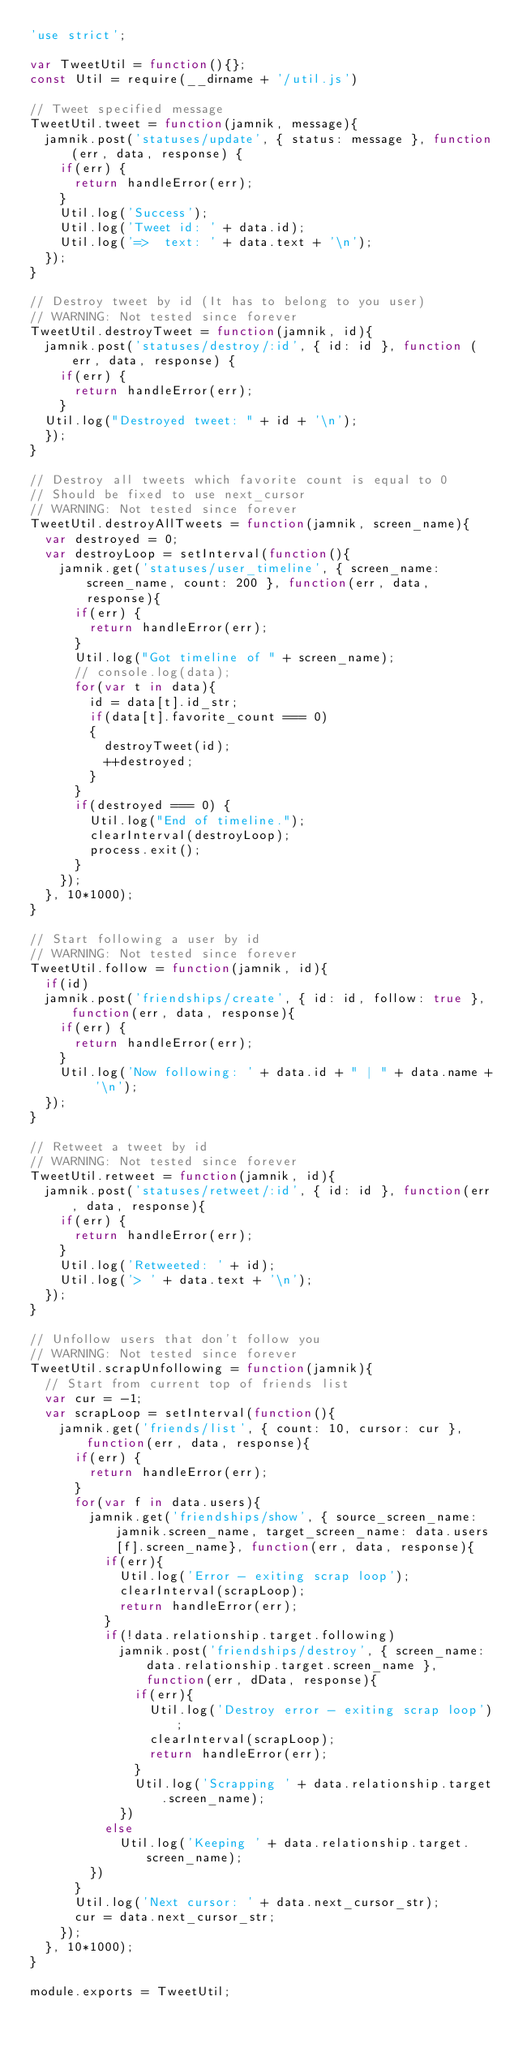<code> <loc_0><loc_0><loc_500><loc_500><_JavaScript_>'use strict';

var TweetUtil = function(){};
const Util = require(__dirname + '/util.js')

// Tweet specified message
TweetUtil.tweet = function(jamnik, message){
  jamnik.post('statuses/update', { status: message }, function(err, data, response) {
    if(err) {
      return handleError(err);
    }
    Util.log('Success');
    Util.log('Tweet id: ' + data.id);
    Util.log('=>  text: ' + data.text + '\n');
  });
}

// Destroy tweet by id (It has to belong to you user)
// WARNING: Not tested since forever
TweetUtil.destroyTweet = function(jamnik, id){
  jamnik.post('statuses/destroy/:id', { id: id }, function (err, data, response) {
    if(err) {
      return handleError(err);
    }
  Util.log("Destroyed tweet: " + id + '\n');
  });
}

// Destroy all tweets which favorite count is equal to 0
// Should be fixed to use next_cursor
// WARNING: Not tested since forever
TweetUtil.destroyAllTweets = function(jamnik, screen_name){
  var destroyed = 0;
  var destroyLoop = setInterval(function(){
    jamnik.get('statuses/user_timeline', { screen_name: screen_name, count: 200 }, function(err, data, response){
      if(err) {
        return handleError(err);
      }
      Util.log("Got timeline of " + screen_name);
      // console.log(data);
      for(var t in data){
        id = data[t].id_str;
        if(data[t].favorite_count === 0)
        {
          destroyTweet(id);
          ++destroyed;
        }
      }
      if(destroyed === 0) {
        Util.log("End of timeline.");
        clearInterval(destroyLoop);
        process.exit();
      }
    });
  }, 10*1000);
}

// Start following a user by id
// WARNING: Not tested since forever
TweetUtil.follow = function(jamnik, id){
  if(id)
  jamnik.post('friendships/create', { id: id, follow: true }, function(err, data, response){
    if(err) {
      return handleError(err);
    }
    Util.log('Now following: ' + data.id + " | " + data.name + '\n');
  });
}

// Retweet a tweet by id
// WARNING: Not tested since forever
TweetUtil.retweet = function(jamnik, id){
  jamnik.post('statuses/retweet/:id', { id: id }, function(err, data, response){
    if(err) {
      return handleError(err);
    }
    Util.log('Retweeted: ' + id);
    Util.log('> ' + data.text + '\n');
  }); 
}

// Unfollow users that don't follow you
// WARNING: Not tested since forever
TweetUtil.scrapUnfollowing = function(jamnik){
  // Start from current top of friends list
  var cur = -1;
  var scrapLoop = setInterval(function(){
    jamnik.get('friends/list', { count: 10, cursor: cur }, function(err, data, response){
      if(err) {
        return handleError(err);
      }
      for(var f in data.users){
        jamnik.get('friendships/show', { source_screen_name: jamnik.screen_name, target_screen_name: data.users[f].screen_name}, function(err, data, response){
          if(err){
            Util.log('Error - exiting scrap loop');
            clearInterval(scrapLoop);
            return handleError(err);
          }
          if(!data.relationship.target.following)
            jamnik.post('friendships/destroy', { screen_name: data.relationship.target.screen_name }, function(err, dData, response){
              if(err){
                Util.log('Destroy error - exiting scrap loop');
                clearInterval(scrapLoop);
                return handleError(err);
              }
              Util.log('Scrapping ' + data.relationship.target.screen_name);
            })
          else
            Util.log('Keeping ' + data.relationship.target.screen_name);
        })
      }
      Util.log('Next cursor: ' + data.next_cursor_str);
      cur = data.next_cursor_str;
    });
  }, 10*1000);
}

module.exports = TweetUtil;</code> 